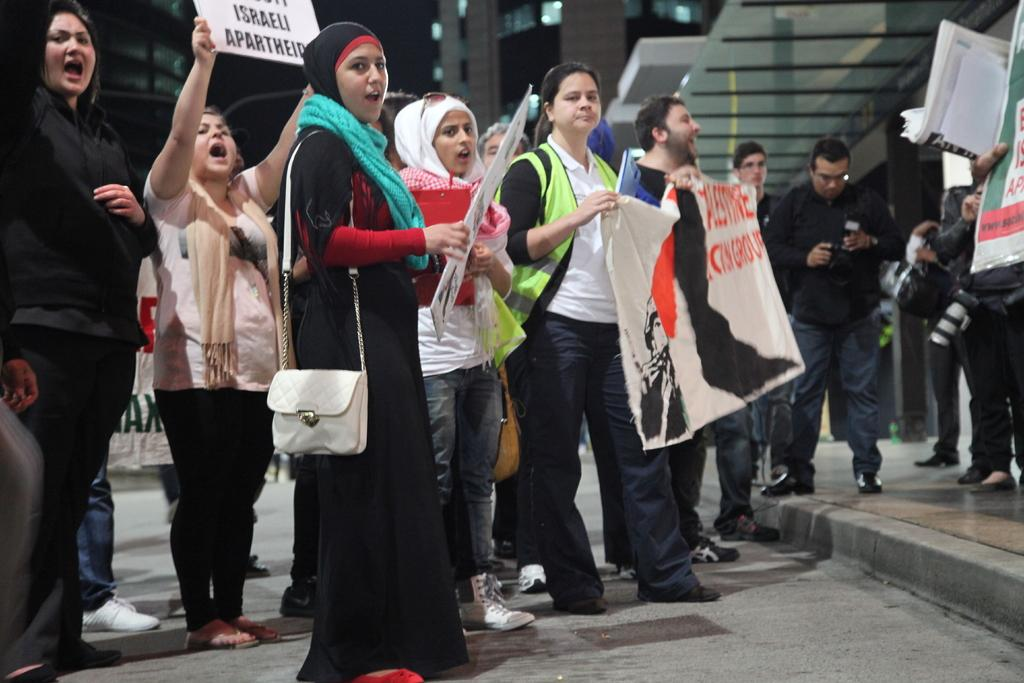What types of people are present in the image? There are men and women in the image. What are the people in the image doing? The people are protesting. What are the people holding in their hands? They are holding banners and posters in their hands. What can be seen in the background of the image? There are buildings in the background of the image. What type of bottle can be seen being passed around during the protest? There is no bottle present in the image; the people are holding banners and posters. 